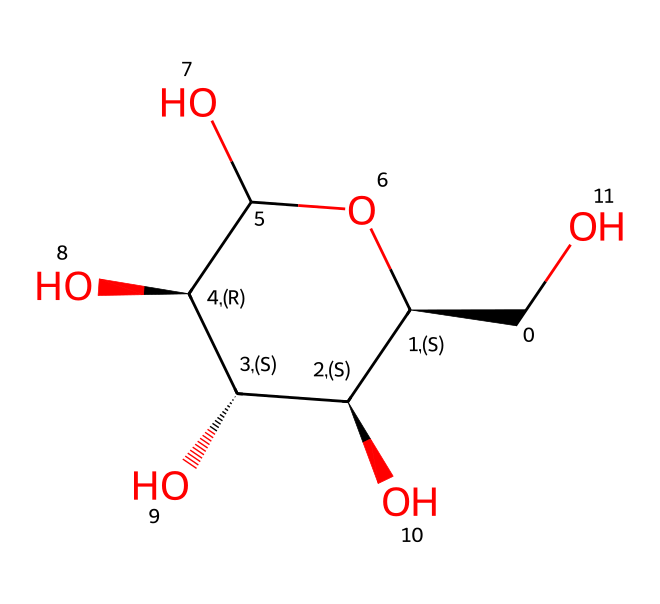What is the molecular formula of glucose? The molecular formula can be deduced by counting the atoms of each element present in the chemical structure. In this case, there are 6 carbon atoms, 12 hydrogen atoms, and 6 oxygen atoms, leading to the formula C6H12O6.
Answer: C6H12O6 How many hydroxyl groups are present in this structure? The hydroxyl group (-OH) can be identified by looking for oxygen atoms connected to hydrogen atoms. In the glucose structure, there are 5 hydroxyl groups present, corresponding to the 5 -OH functional groups attached to carbon atoms.
Answer: 5 What type of carbohydrate is represented by this structure? The structure is a monosaccharide due to the presence of a single sugar unit without any additional links to other sugar units. Monosaccharides are classified as the simplest form of carbohydrates, which glucose is.
Answer: monosaccharide How many chiral centers are present in glucose? Chiral centers are identified by looking for carbon atoms that have four different substituents attached. In the glucose structure, there are 4 chiral centers located at carbon atoms 2, 3, 4, and 5.
Answer: 4 What is the stereochemistry designation of the first carbon in this glucose structure? The first carbon in the structure has a specific stereochemical arrangement as it is connected to four different groups. Since it is given a specific chirality designation (C@H), this indicates that it has a particular 3D arrangement as defined by the 'S' or 'R' notation in stereochemistry.
Answer: R Which functional group is primarily responsible for the sweetness of glucose? The presence of the hydroxyl (-OH) functional groups contributes to the sweetness of glucose. These groups facilitate hydrogen bonding with taste receptors, leading to the sweet flavor profile of glucose.
Answer: hydroxyl How many rings does this glucose structure contain? The structure shows a cyclic form of glucose known as a pyranose ring, which is formed by the reaction of the hydroxyl group with a carbonyl group in an open-chain structure. Since it is a single cyclic molecule, there is one ring present here.
Answer: 1 